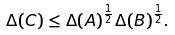<formula> <loc_0><loc_0><loc_500><loc_500>\Delta ( C ) \leq \Delta ( A ) ^ { \frac { 1 } { 2 } } \Delta ( B ) ^ { \frac { 1 } { 2 } } .</formula> 